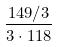Convert formula to latex. <formula><loc_0><loc_0><loc_500><loc_500>\frac { 1 4 9 / 3 } { 3 \cdot 1 1 8 }</formula> 